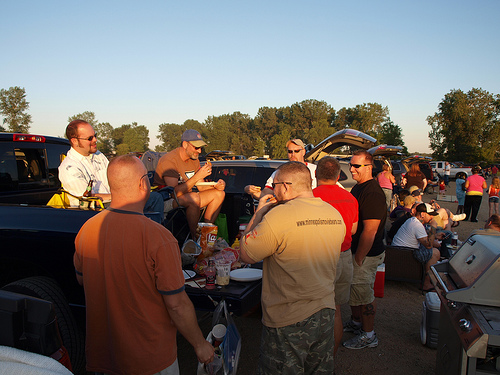<image>
Can you confirm if the man is in front of the truck? Yes. The man is positioned in front of the truck, appearing closer to the camera viewpoint. 